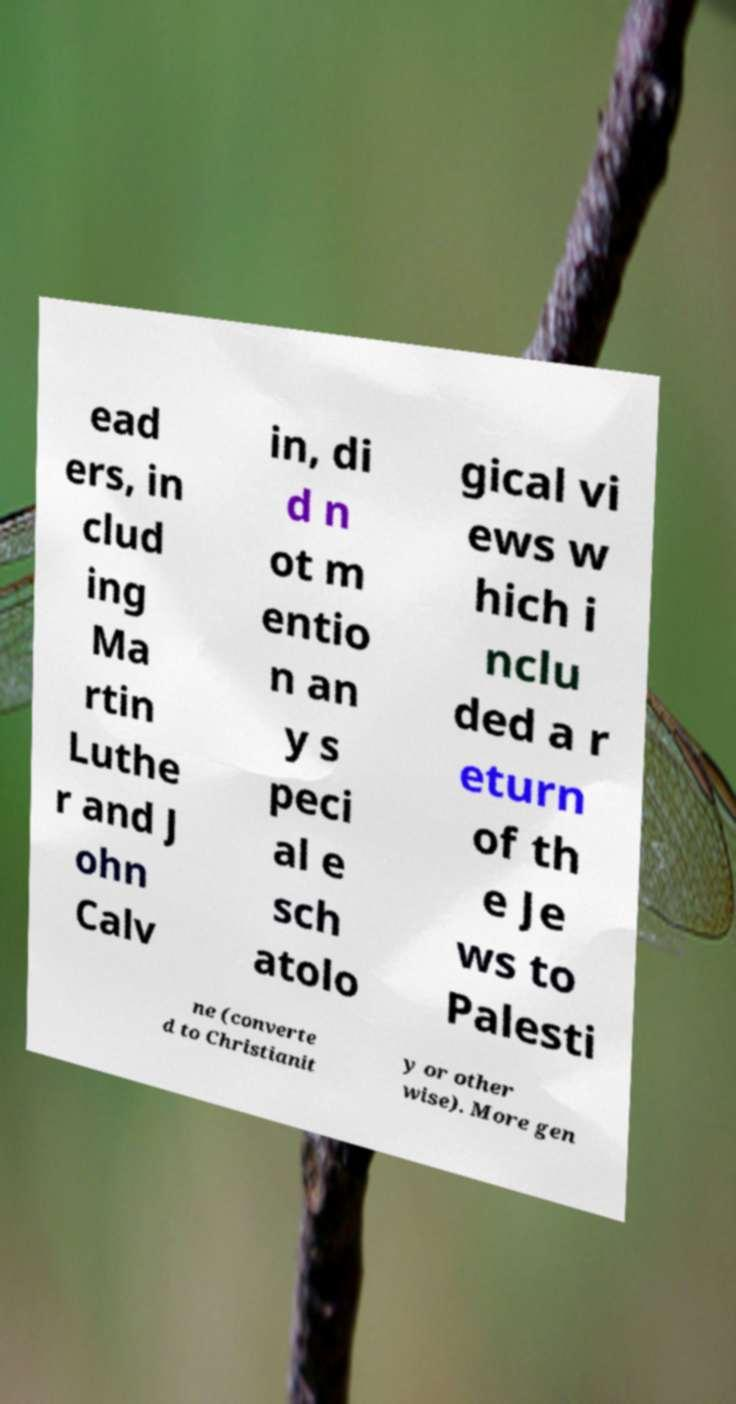Could you assist in decoding the text presented in this image and type it out clearly? ead ers, in clud ing Ma rtin Luthe r and J ohn Calv in, di d n ot m entio n an y s peci al e sch atolo gical vi ews w hich i nclu ded a r eturn of th e Je ws to Palesti ne (converte d to Christianit y or other wise). More gen 